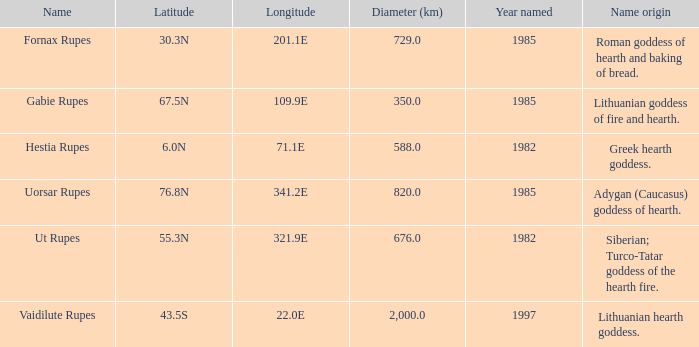5n, what is the width? 350.0. 